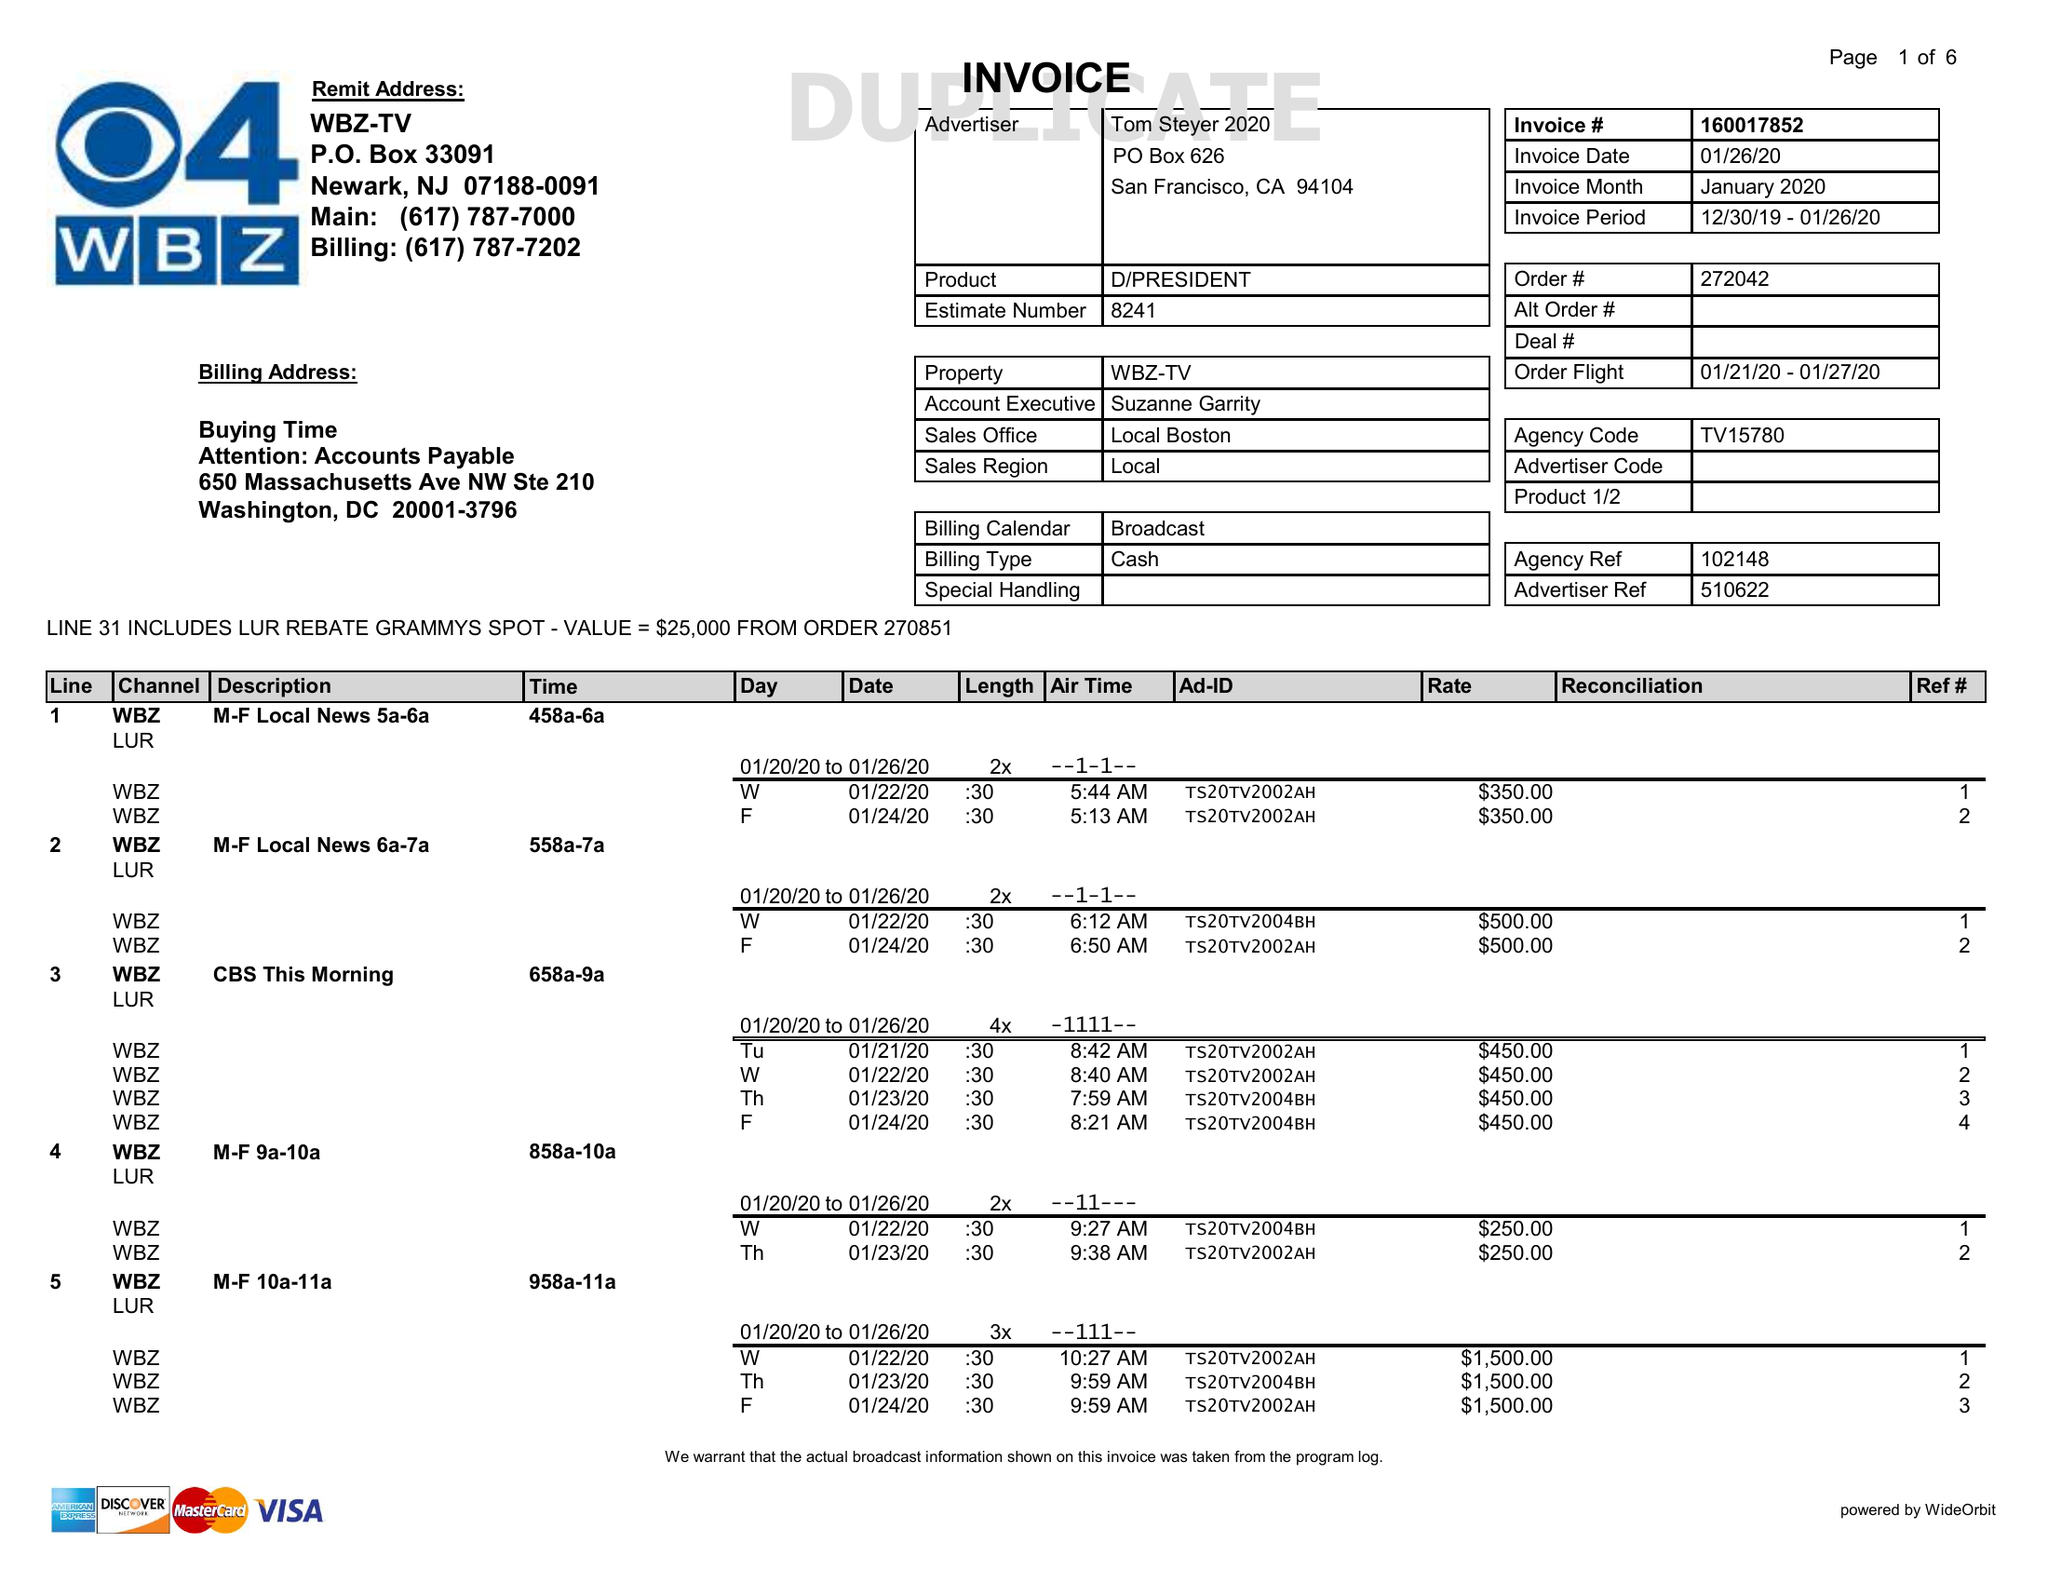What is the value for the contract_num?
Answer the question using a single word or phrase. 160017852 